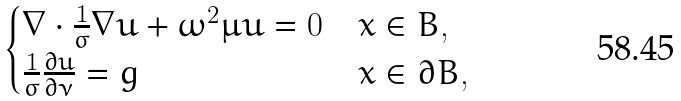Convert formula to latex. <formula><loc_0><loc_0><loc_500><loc_500>\begin{cases} \nabla \cdot \frac { 1 } { \sigma } \nabla u + \omega ^ { 2 } \mu u = 0 & x \in B , \\ \frac { 1 } { \sigma } \frac { \partial u } { \partial \nu } = g & x \in \partial B , \end{cases}</formula> 